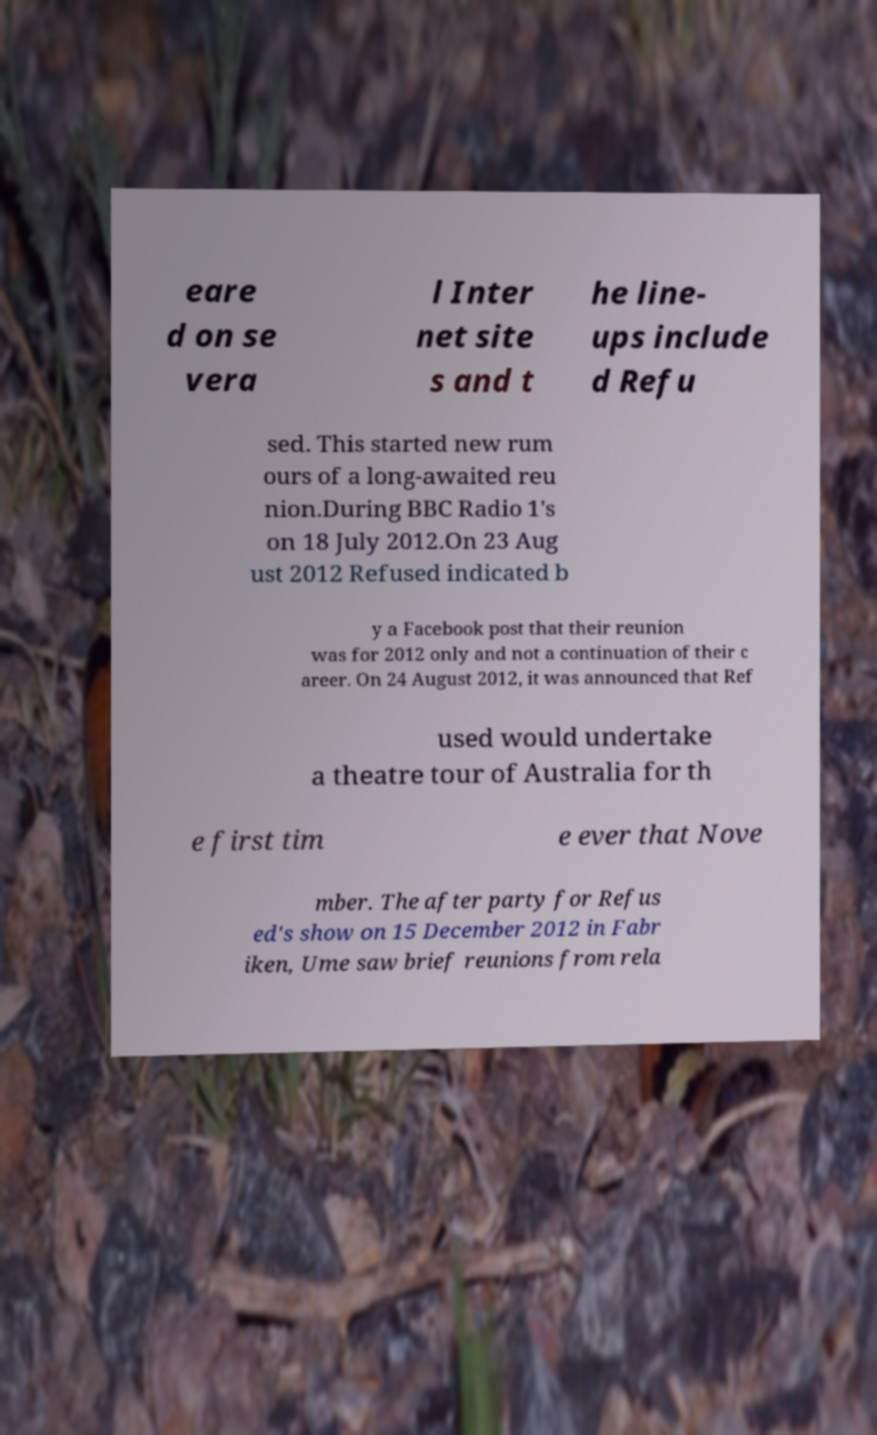Can you read and provide the text displayed in the image?This photo seems to have some interesting text. Can you extract and type it out for me? eare d on se vera l Inter net site s and t he line- ups include d Refu sed. This started new rum ours of a long-awaited reu nion.During BBC Radio 1's on 18 July 2012.On 23 Aug ust 2012 Refused indicated b y a Facebook post that their reunion was for 2012 only and not a continuation of their c areer. On 24 August 2012, it was announced that Ref used would undertake a theatre tour of Australia for th e first tim e ever that Nove mber. The after party for Refus ed's show on 15 December 2012 in Fabr iken, Ume saw brief reunions from rela 